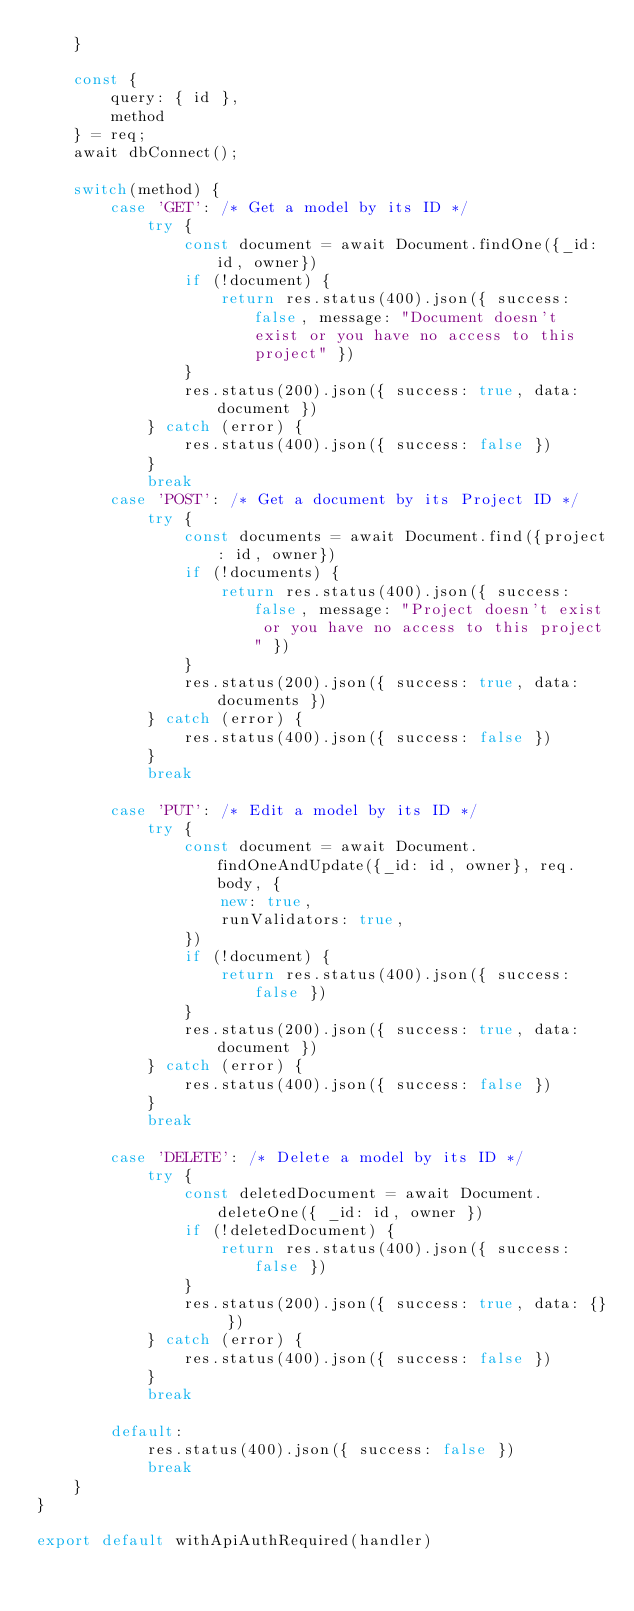Convert code to text. <code><loc_0><loc_0><loc_500><loc_500><_TypeScript_>    }

    const {
        query: { id },
        method
    } = req;
    await dbConnect();

    switch(method) {
        case 'GET': /* Get a model by its ID */
            try {
                const document = await Document.findOne({_id: id, owner})
                if (!document) {
                    return res.status(400).json({ success: false, message: "Document doesn't exist or you have no access to this project" })
                }
                res.status(200).json({ success: true, data: document })
            } catch (error) {
                res.status(400).json({ success: false })
            }
            break
        case 'POST': /* Get a document by its Project ID */
            try {
                const documents = await Document.find({project: id, owner})
                if (!documents) {
                    return res.status(400).json({ success: false, message: "Project doesn't exist or you have no access to this project" })
                }
                res.status(200).json({ success: true, data: documents })
            } catch (error) {
                res.status(400).json({ success: false })
            }
            break

        case 'PUT': /* Edit a model by its ID */
            try {
                const document = await Document.findOneAndUpdate({_id: id, owner}, req.body, {
                    new: true,
                    runValidators: true,
                })
                if (!document) {
                    return res.status(400).json({ success: false })
                }
                res.status(200).json({ success: true, data: document })
            } catch (error) {
                res.status(400).json({ success: false })
            }
            break

        case 'DELETE': /* Delete a model by its ID */
            try {
                const deletedDocument = await Document.deleteOne({ _id: id, owner })
                if (!deletedDocument) {
                    return res.status(400).json({ success: false })
                }
                res.status(200).json({ success: true, data: {} })
            } catch (error) {
                res.status(400).json({ success: false })
            }
            break

        default:
            res.status(400).json({ success: false })
            break
    }
}

export default withApiAuthRequired(handler)</code> 